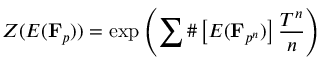<formula> <loc_0><loc_0><loc_500><loc_500>Z ( E ( F _ { p } ) ) = \exp \left ( \sum \# \left [ E ( { F } _ { p ^ { n } } ) \right ] { \frac { T ^ { n } } { n } } \right )</formula> 